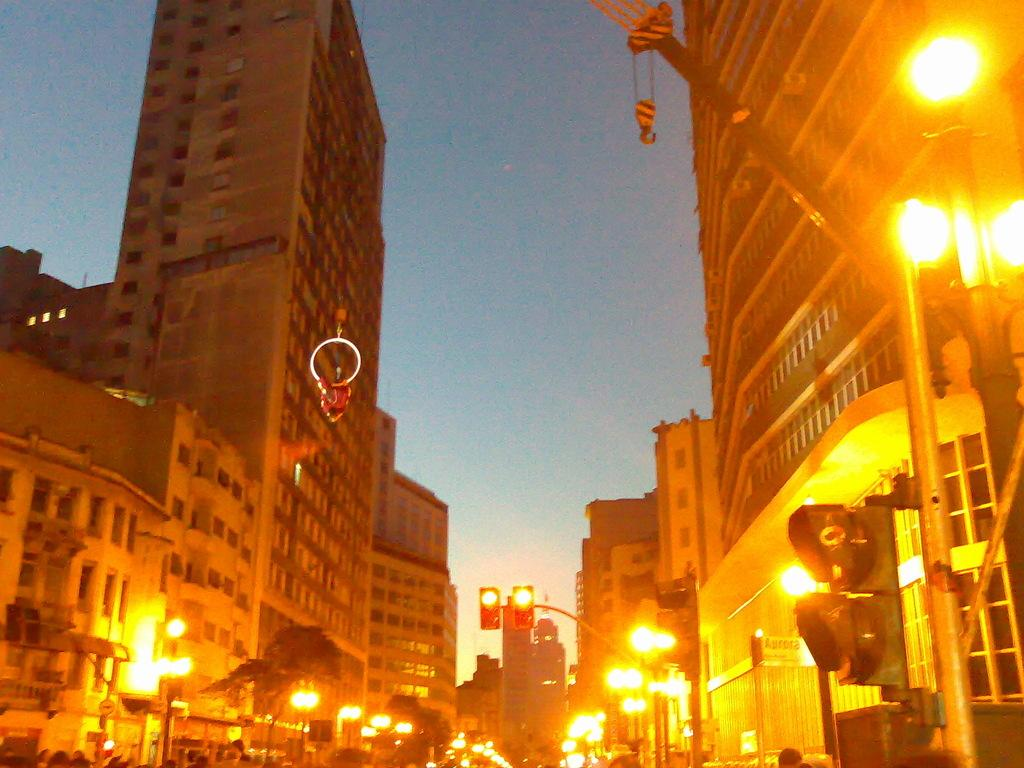What can be seen in the image? There are persons standing in the image, along with lights, poles, traffic signals, a crane, buildings on both sides of the road, and the sky visible in the background. What type of infrastructure is present in the image? The image shows lights, poles, traffic signals, and a crane, which are all part of urban infrastructure. What is the setting of the image? The image appears to be set in an urban area, with buildings on both sides of the road. Can you describe the sky in the image? The sky is visible in the background of the image, but no specific details about its appearance are provided. What type of drug is being sold by the person standing in the image? There is no indication in the image that any person is selling drugs, and therefore no such activity can be observed. What kind of trouble is the crane causing in the image? There is no indication in the image that the crane is causing any trouble; it is simply a part of the urban infrastructure. 